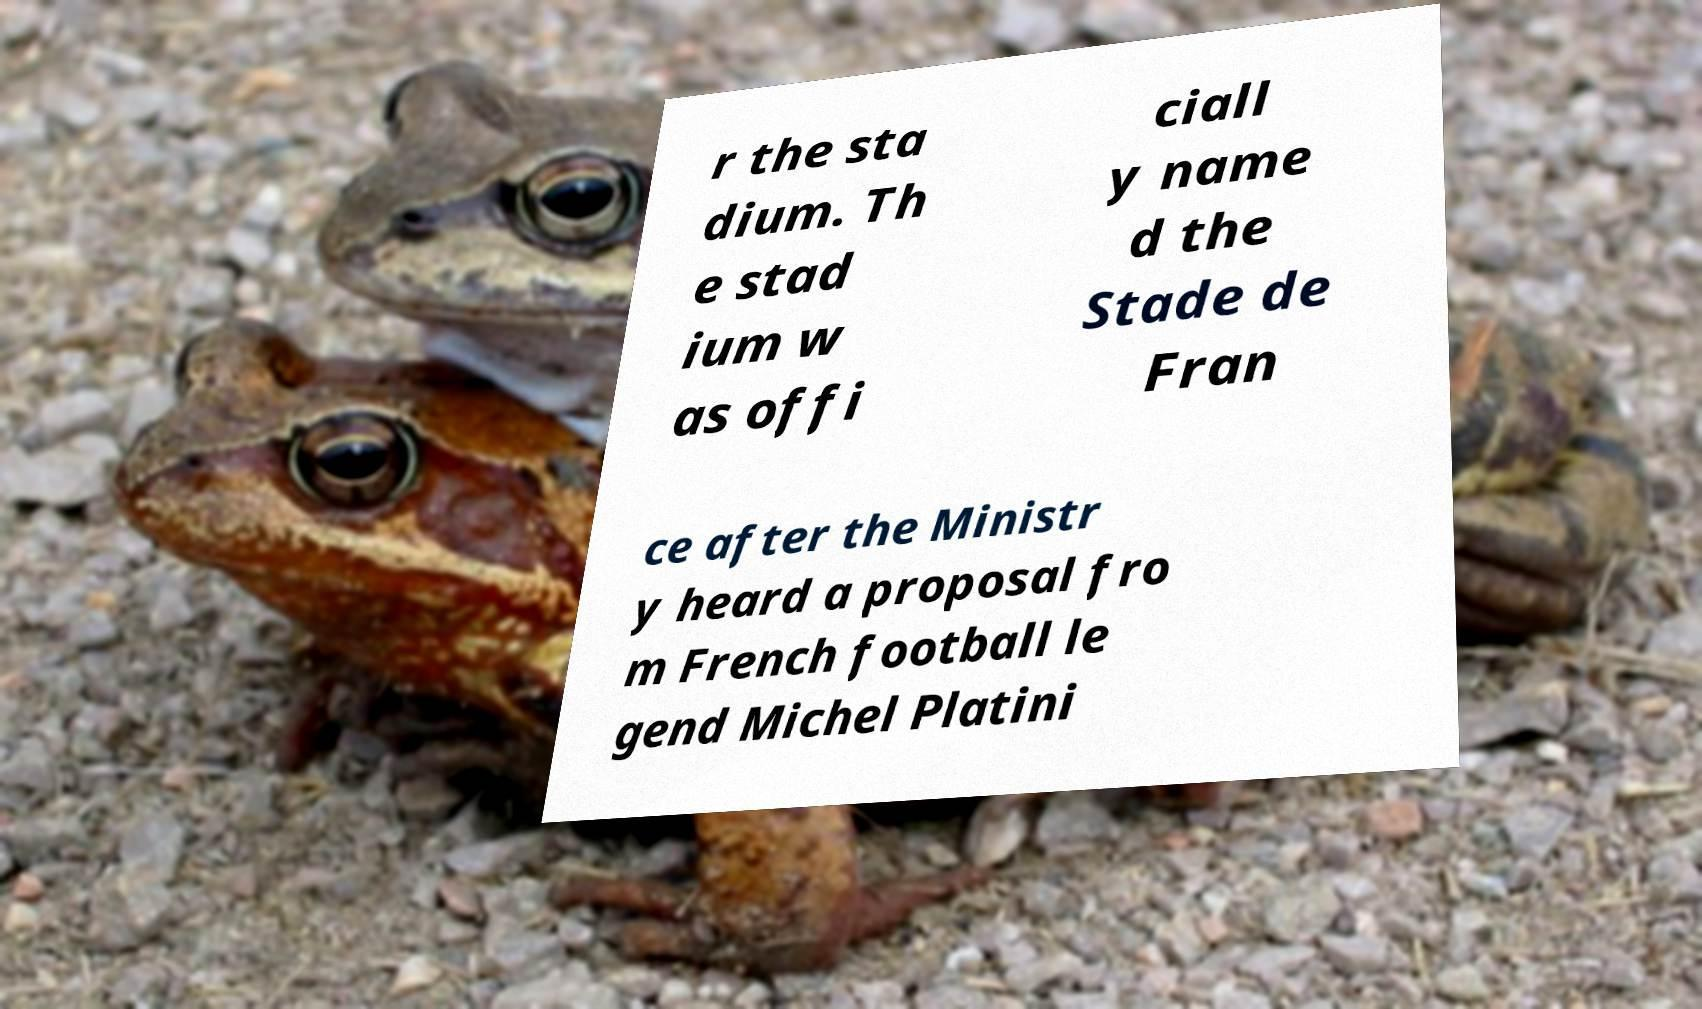Please read and relay the text visible in this image. What does it say? r the sta dium. Th e stad ium w as offi ciall y name d the Stade de Fran ce after the Ministr y heard a proposal fro m French football le gend Michel Platini 